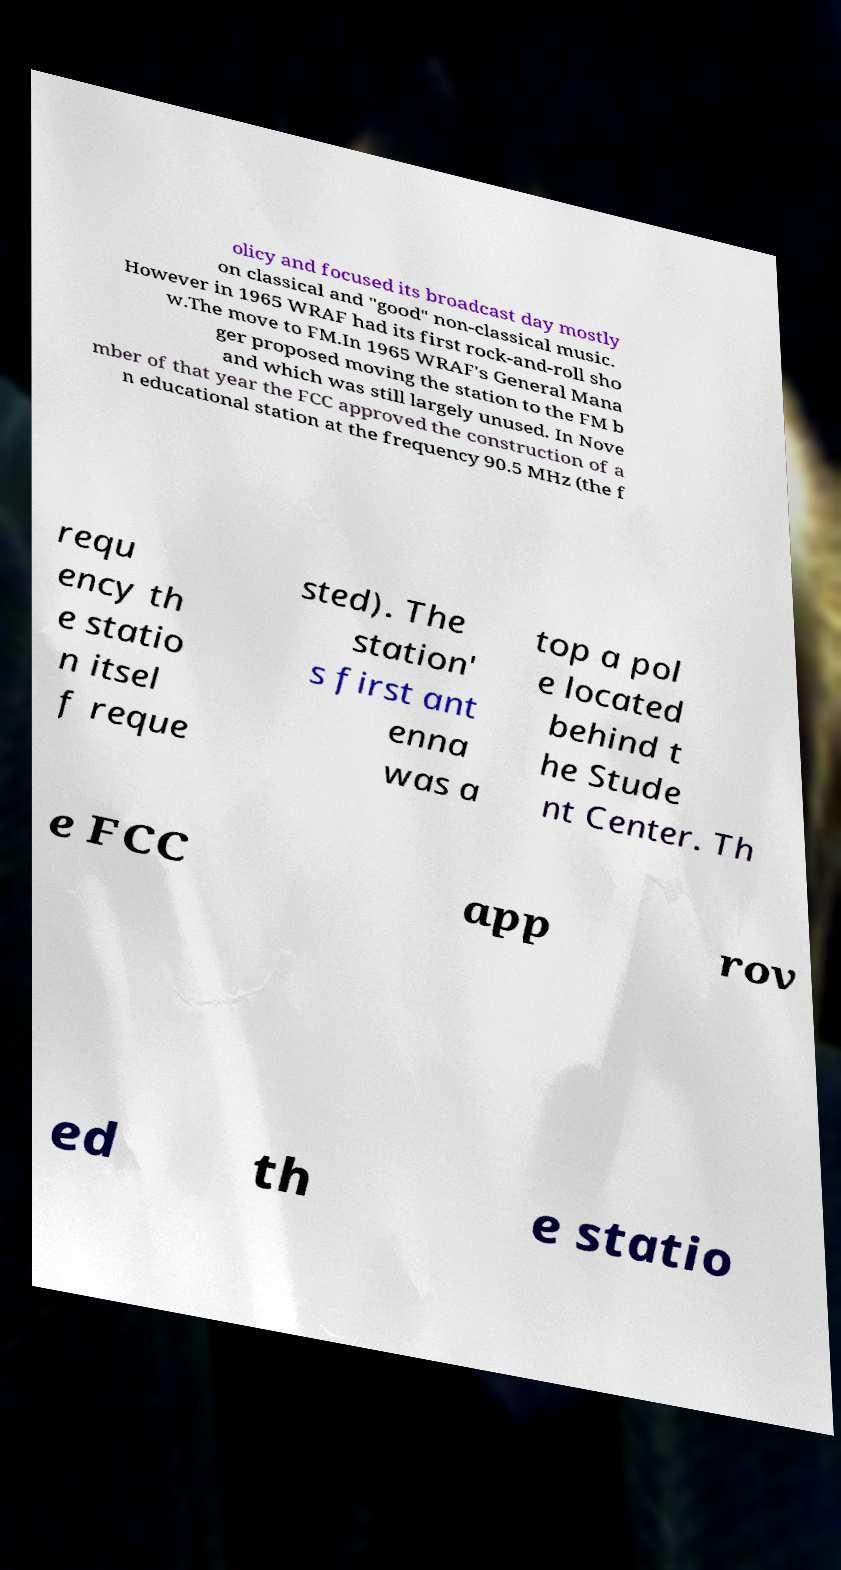For documentation purposes, I need the text within this image transcribed. Could you provide that? olicy and focused its broadcast day mostly on classical and "good" non-classical music. However in 1965 WRAF had its first rock-and-roll sho w.The move to FM.In 1965 WRAF's General Mana ger proposed moving the station to the FM b and which was still largely unused. In Nove mber of that year the FCC approved the construction of a n educational station at the frequency 90.5 MHz (the f requ ency th e statio n itsel f reque sted). The station' s first ant enna was a top a pol e located behind t he Stude nt Center. Th e FCC app rov ed th e statio 